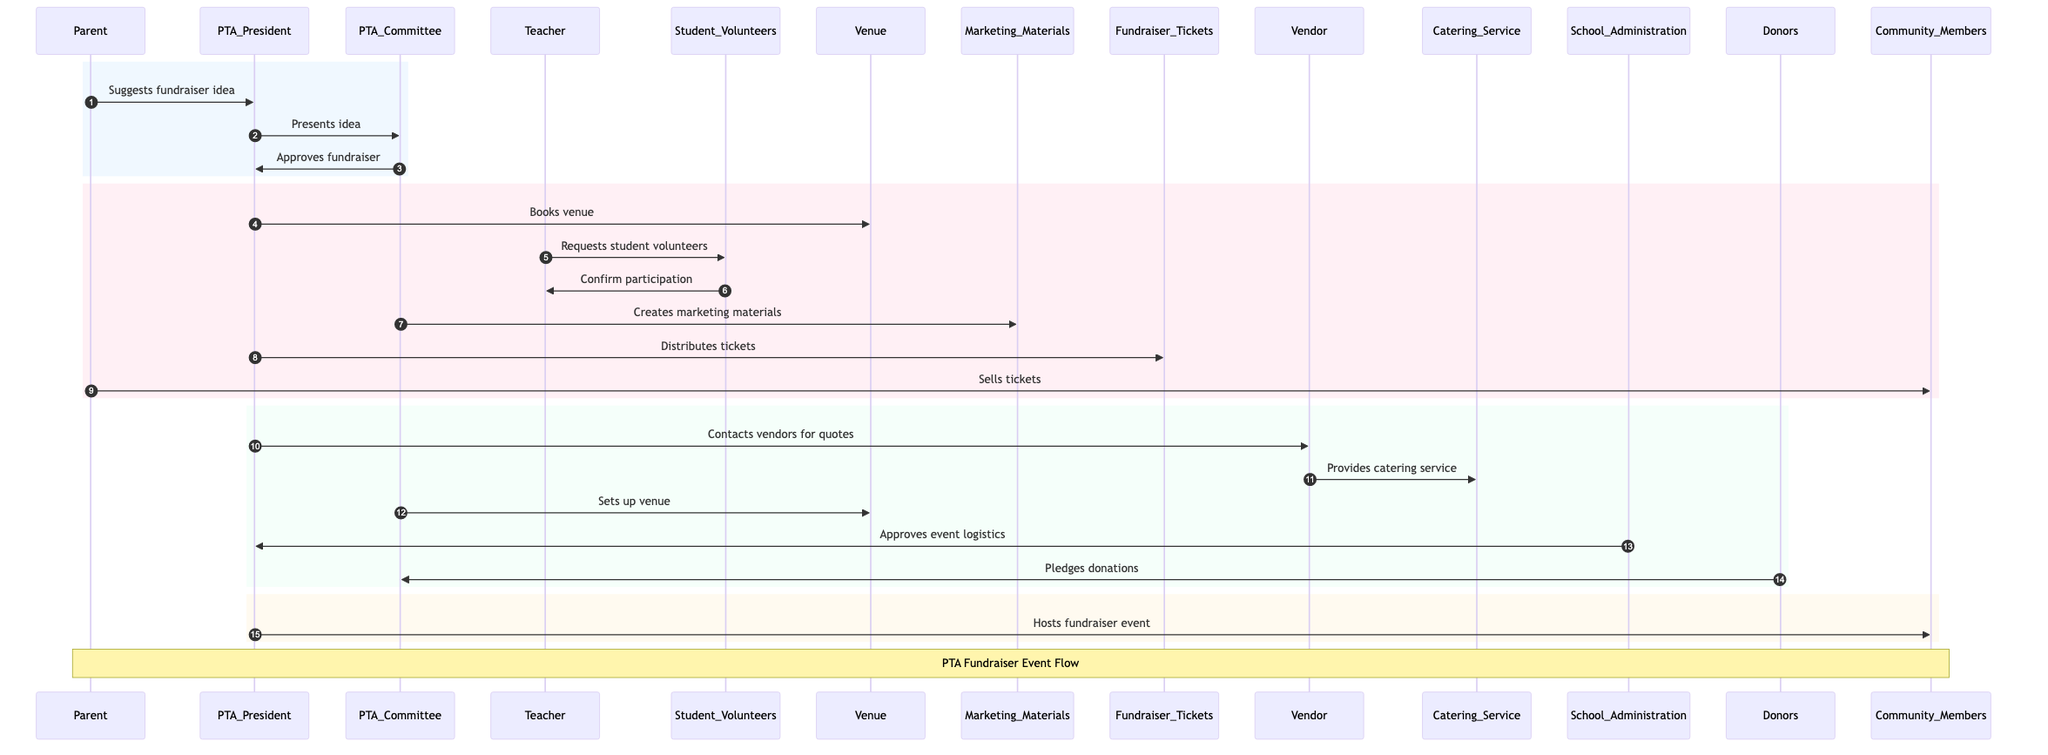What is the first action in the sequence? The diagram starts with the Parent suggesting a fundraiser idea to the PTA President, making it the first action in the sequence.
Answer: Suggests fundraiser idea How many actors are involved in the fundraiser process? By counting the different participants listed in the diagram, we find there are a total of 7 actors involved in the fundraiser process.
Answer: 7 Which actor creates marketing materials? The PTA Committee is the actor that is responsible for creating the marketing materials in the sequence.
Answer: PTA Committee What step follows after the PTA Committee approves the fundraiser? After the PTA Committee approves the fundraiser, the PTA President proceeds to book the venue for the event, making it the subsequent step.
Answer: Books venue Who sells the tickets? The Parent is responsible for selling the tickets to the community members as depicted in the sequence.
Answer: Parent Which actor is responsible for contacting vendors? The PTA President contacts vendors for quotes, and this is depicted as a key action in the sequence.
Answer: PTA President How many different phases are segmented in the sequence? The diagram is divided into four distinct phases for clarity, each marked with different colored sections to represent different stages of the event planning.
Answer: 4 What is the last action in the sequence? The last action performed in the sequence is the PTA President hosting the fundraiser event for the community members.
Answer: Hosts fundraiser event What do the donors do in this process? The donors pledge their donations to the PTA Committee, and this is captured in the sequence as a collaborative effort for the fundraiser.
Answer: Pledges donations 